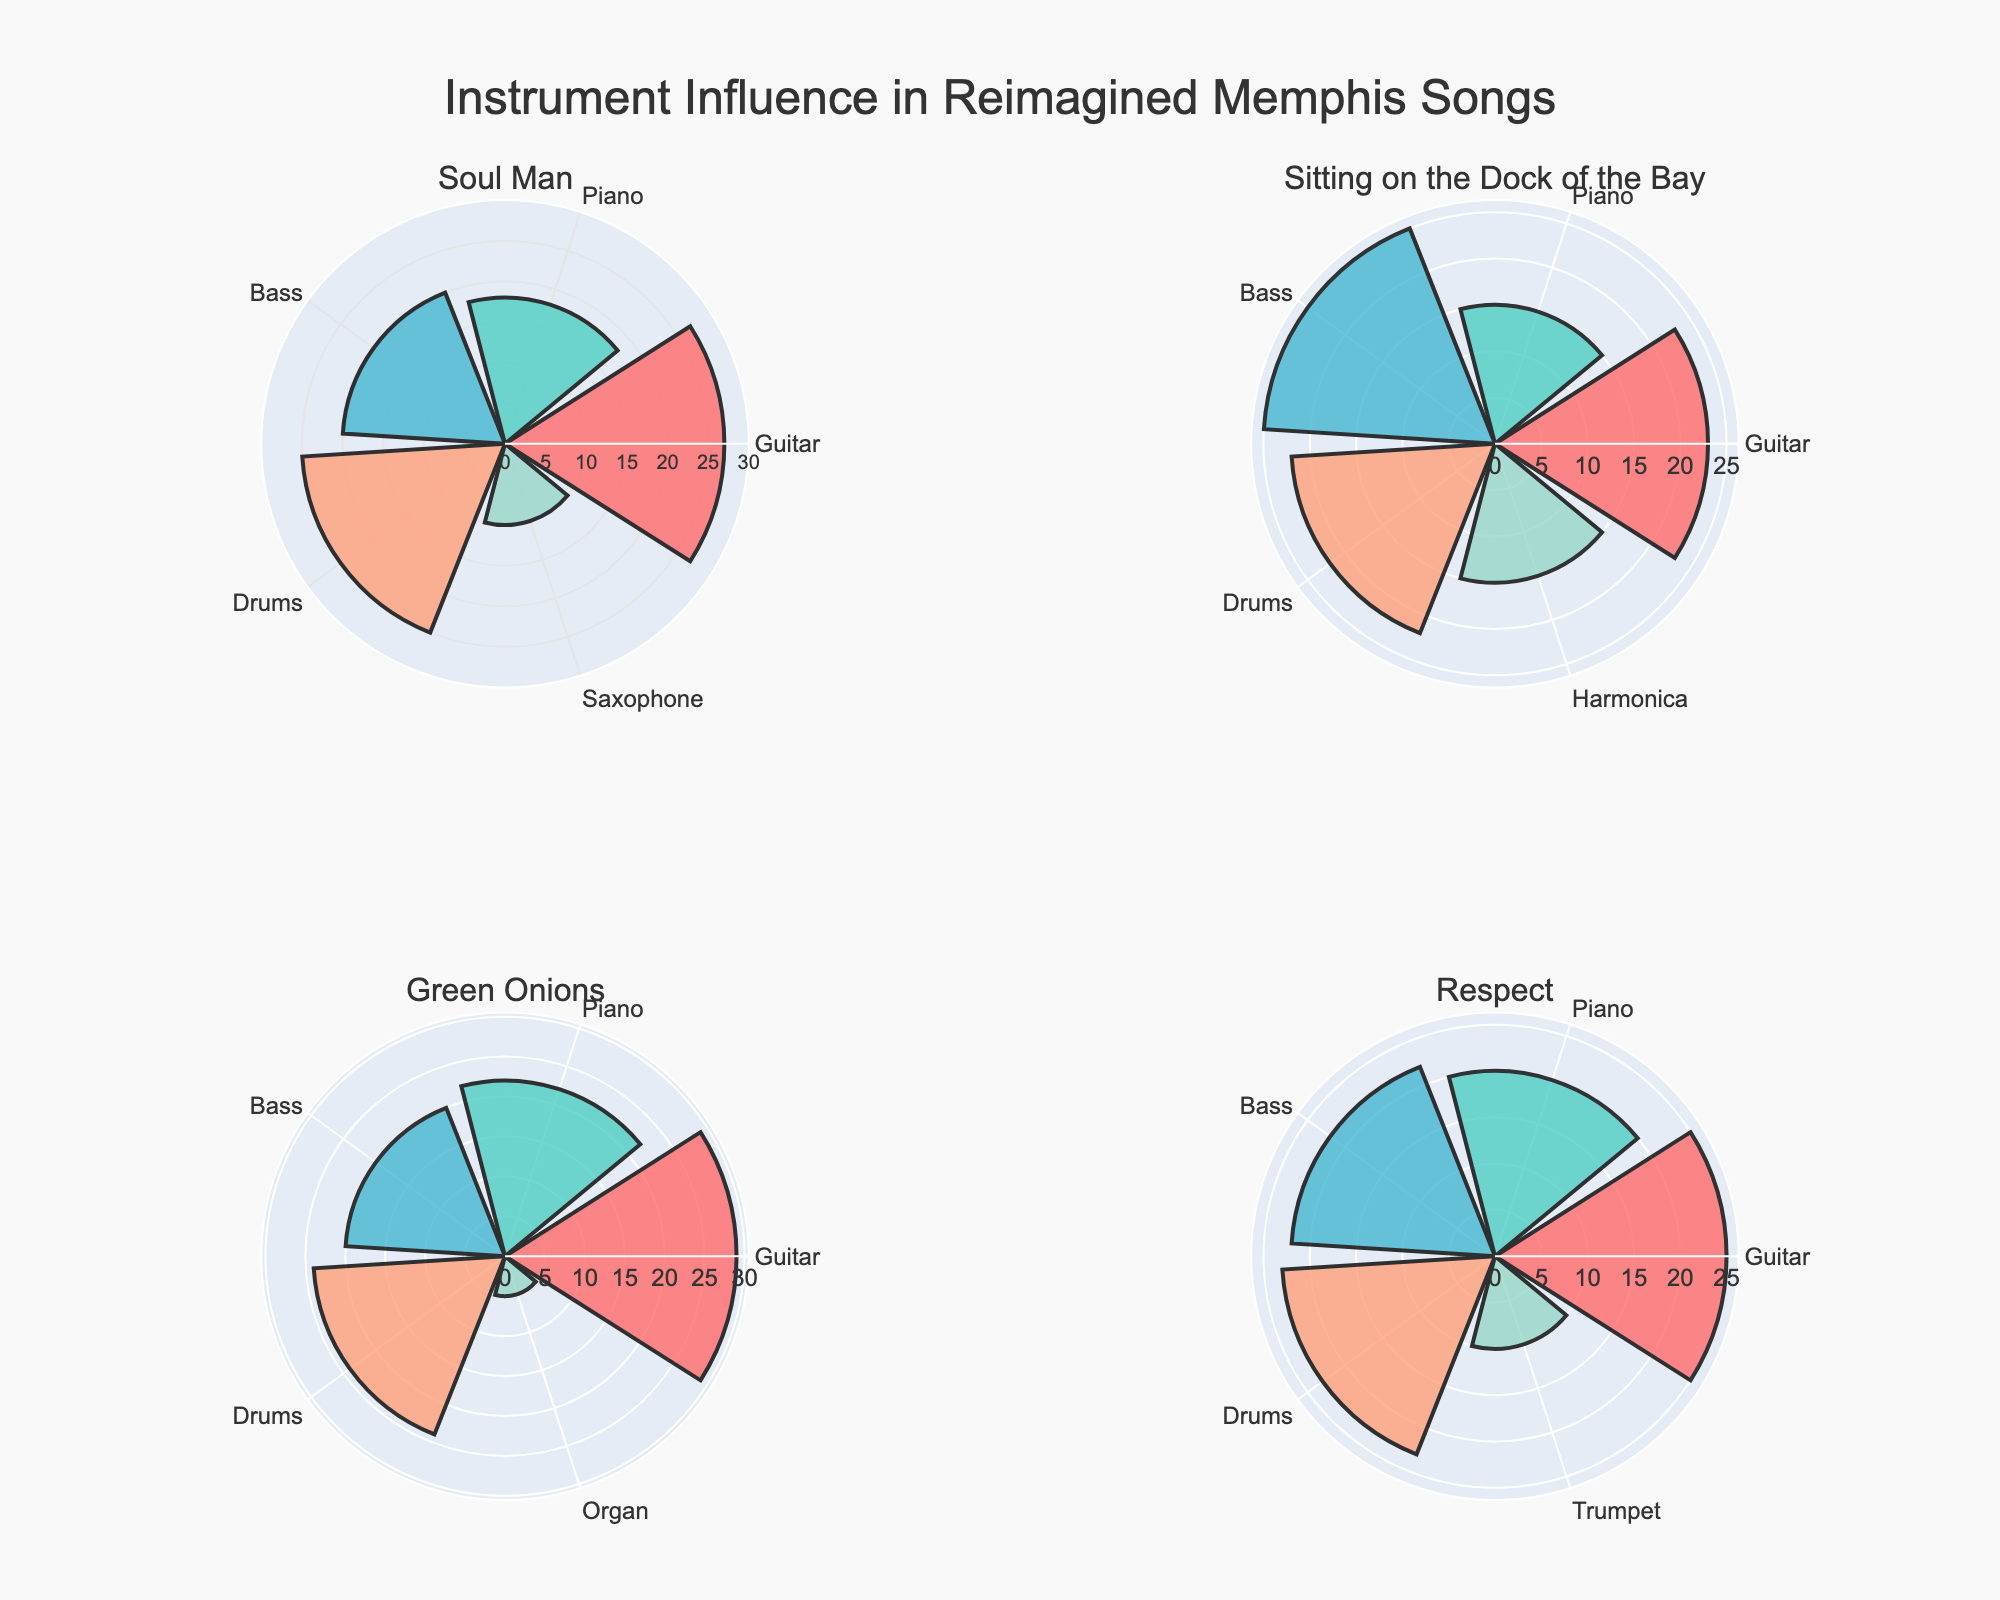What is the title of the plot? The title of the plot is shown at the top and reads "Instrument Influence in Reimagined Memphis Songs".
Answer: Instrument Influence in Reimagined Memphis Songs Which instrument has the highest influence percentage on the song 'Soul Man'? By looking at the 'Soul Man' subplot, the instrument with the largest bar is the Guitar, with an influence percentage of 27.
Answer: Guitar What is the total influence percentage of all instruments on the song 'Sitting on the Dock of the Bay'? Sum the influence percentages for all instruments in the subplot 'Sitting on the Dock of the Bay': 23 (Guitar) + 15 (Piano) + 25 (Bass) + 22 (Drums) + 15 (Harmonica) = 100.
Answer: 100 Which song has the lowest influence percentage for any single instrument and what is that percentage? By checking each song subplot, the 'Green Onions' song has the lowest influence percentage for a single instrument, which is the Organ with 5.
Answer: Green Onions, 5 In 'Respect', which instrument's influence is equal to the combined influence of Piano and Trumpet? The combined influence of Piano and Trumpet in 'Respect' is 20 (Piano) + 10 (Trumpet) = 30. No single instrument has an influence of 30.
Answer: None Compare the influence of Guitar and Bass in 'Green Onions'. Which one has a higher influence percentage and by how much? The Guitar has an influence of 29 and the Bass has 20 in 'Green Onions'. The difference is 29 - 20 = 9.
Answer: Guitar, 9 What is the average influence percentage of the instruments in the song 'Soul Man'? The influence percentages in 'Soul Man' are: 27 (Guitar), 18 (Piano), 20 (Bass), 25 (Drums), and 10 (Saxophone). The sum is 27 + 18 + 20 + 25 + 10 = 100. The average is 100 / 5 = 20.
Answer: 20 In 'Green Onions', how does the influence of the Drums compare to the influence of the Organ? The Drums have an influence percentage of 24, and the Organ has 5. The Drums have 24 - 5 = 19 more influence percentage than the Organ.
Answer: 19 Which instrument appears in all songs and what's its influence percentage in each? The Guitar appears in all songs. Its influence percentages are 27 (Soul Man), 23 (Sitting on the Dock of the Bay), 29 (Green Onions), and 25 (Respect).
Answer: Guitar: 27 (Soul Man), 23 (Sitting on the Dock of the Bay), 29 (Green Onions), 25 (Respect) What's the influence percentage of the Drums in 'Respect' compared to 'Sitting on the Dock of the Bay'? The influence percentage of the Drums in 'Respect' is 23, and in 'Sitting on the Dock of the Bay' it's 22. Respect's Drums have 23 - 22 = 1 more influence than 'Sitting on the Dock of the Bay'.
Answer: 1 